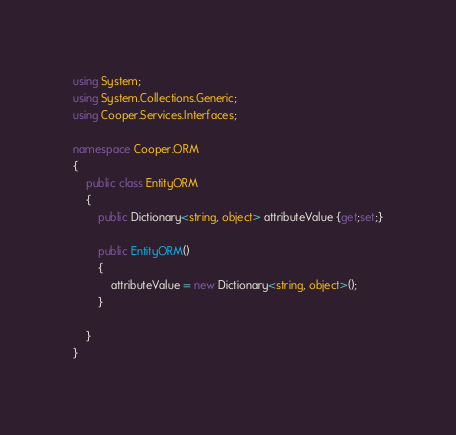<code> <loc_0><loc_0><loc_500><loc_500><_C#_>using System;
using System.Collections.Generic;
using Cooper.Services.Interfaces;

namespace Cooper.ORM
{
    public class EntityORM
    {
        public Dictionary<string, object> attributeValue {get;set;}

        public EntityORM()
        {
            attributeValue = new Dictionary<string, object>();
        }

    }
}</code> 